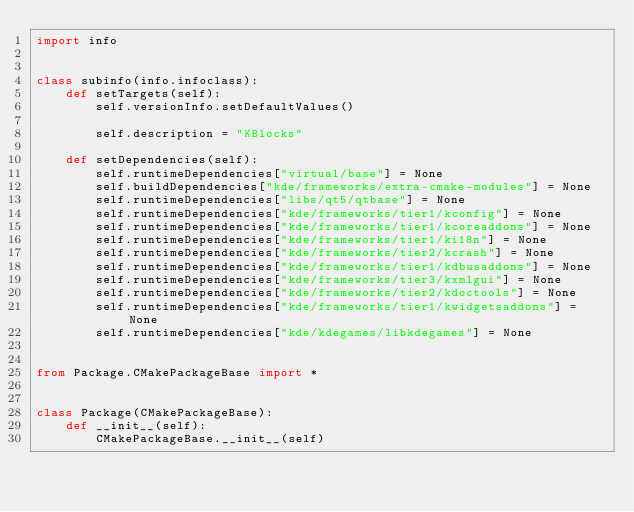<code> <loc_0><loc_0><loc_500><loc_500><_Python_>import info


class subinfo(info.infoclass):
    def setTargets(self):
        self.versionInfo.setDefaultValues()

        self.description = "KBlocks"

    def setDependencies(self):
        self.runtimeDependencies["virtual/base"] = None
        self.buildDependencies["kde/frameworks/extra-cmake-modules"] = None
        self.runtimeDependencies["libs/qt5/qtbase"] = None
        self.runtimeDependencies["kde/frameworks/tier1/kconfig"] = None
        self.runtimeDependencies["kde/frameworks/tier1/kcoreaddons"] = None
        self.runtimeDependencies["kde/frameworks/tier1/ki18n"] = None
        self.runtimeDependencies["kde/frameworks/tier2/kcrash"] = None
        self.runtimeDependencies["kde/frameworks/tier1/kdbusaddons"] = None
        self.runtimeDependencies["kde/frameworks/tier3/kxmlgui"] = None
        self.runtimeDependencies["kde/frameworks/tier2/kdoctools"] = None
        self.runtimeDependencies["kde/frameworks/tier1/kwidgetsaddons"] = None
        self.runtimeDependencies["kde/kdegames/libkdegames"] = None


from Package.CMakePackageBase import *


class Package(CMakePackageBase):
    def __init__(self):
        CMakePackageBase.__init__(self)
</code> 